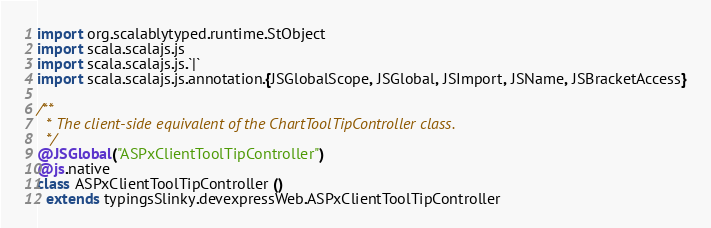Convert code to text. <code><loc_0><loc_0><loc_500><loc_500><_Scala_>
import org.scalablytyped.runtime.StObject
import scala.scalajs.js
import scala.scalajs.js.`|`
import scala.scalajs.js.annotation.{JSGlobalScope, JSGlobal, JSImport, JSName, JSBracketAccess}

/**
  * The client-side equivalent of the ChartToolTipController class.
  */
@JSGlobal("ASPxClientToolTipController")
@js.native
class ASPxClientToolTipController ()
  extends typingsSlinky.devexpressWeb.ASPxClientToolTipController
</code> 